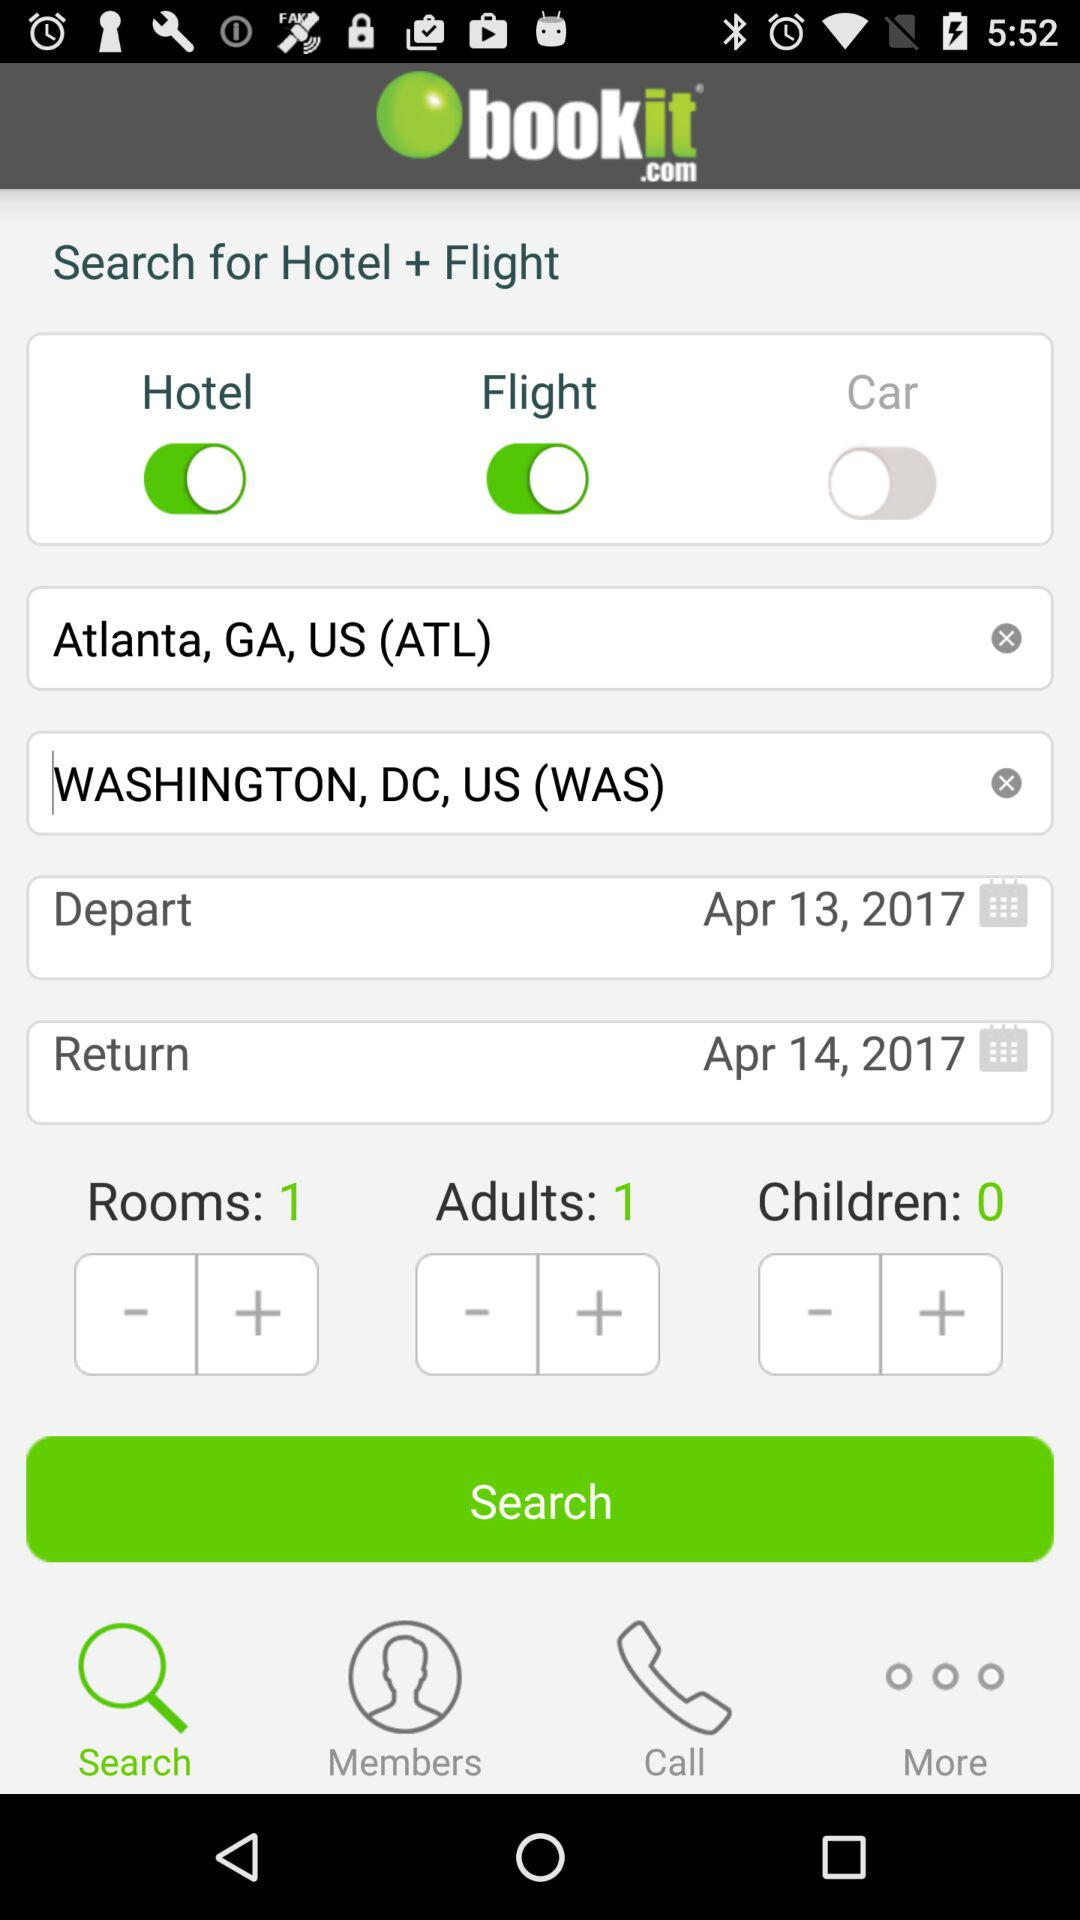What is the selected destination city? The selected destination city is Washington, DC, US (WAS). 